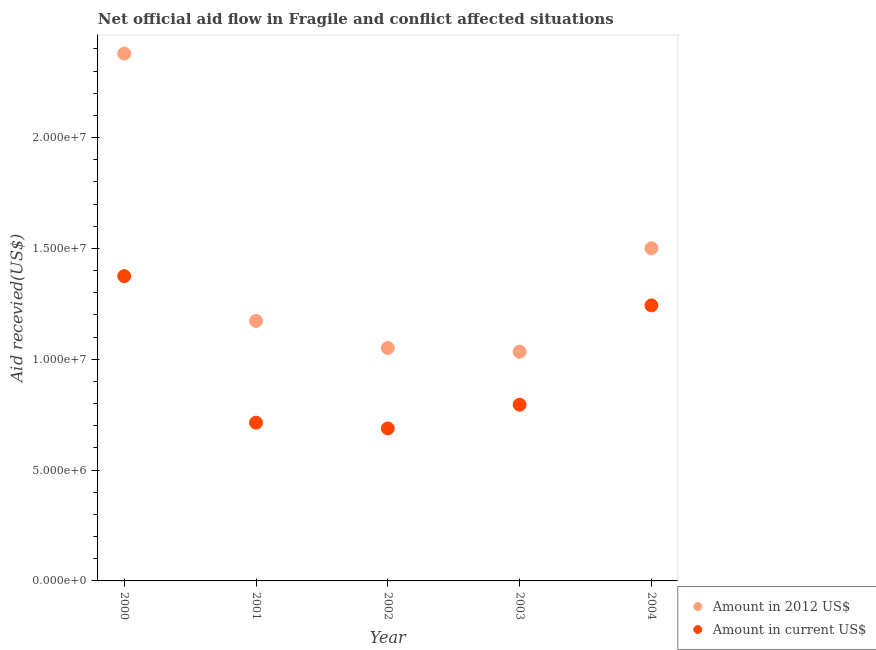How many different coloured dotlines are there?
Offer a terse response. 2. Is the number of dotlines equal to the number of legend labels?
Your answer should be very brief. Yes. What is the amount of aid received(expressed in 2012 us$) in 2003?
Give a very brief answer. 1.03e+07. Across all years, what is the maximum amount of aid received(expressed in us$)?
Provide a succinct answer. 1.38e+07. Across all years, what is the minimum amount of aid received(expressed in 2012 us$)?
Keep it short and to the point. 1.03e+07. In which year was the amount of aid received(expressed in 2012 us$) minimum?
Give a very brief answer. 2003. What is the total amount of aid received(expressed in us$) in the graph?
Your answer should be compact. 4.82e+07. What is the difference between the amount of aid received(expressed in us$) in 2000 and that in 2001?
Provide a succinct answer. 6.61e+06. What is the difference between the amount of aid received(expressed in 2012 us$) in 2002 and the amount of aid received(expressed in us$) in 2000?
Provide a short and direct response. -3.24e+06. What is the average amount of aid received(expressed in us$) per year?
Provide a succinct answer. 9.63e+06. In the year 2001, what is the difference between the amount of aid received(expressed in us$) and amount of aid received(expressed in 2012 us$)?
Your answer should be compact. -4.59e+06. What is the ratio of the amount of aid received(expressed in us$) in 2002 to that in 2003?
Ensure brevity in your answer.  0.87. Is the amount of aid received(expressed in us$) in 2001 less than that in 2003?
Your response must be concise. Yes. Is the difference between the amount of aid received(expressed in us$) in 2001 and 2004 greater than the difference between the amount of aid received(expressed in 2012 us$) in 2001 and 2004?
Your response must be concise. No. What is the difference between the highest and the second highest amount of aid received(expressed in us$)?
Make the answer very short. 1.32e+06. What is the difference between the highest and the lowest amount of aid received(expressed in 2012 us$)?
Your response must be concise. 1.34e+07. Does the amount of aid received(expressed in us$) monotonically increase over the years?
Your answer should be very brief. No. How many years are there in the graph?
Your answer should be very brief. 5. Does the graph contain any zero values?
Make the answer very short. No. How are the legend labels stacked?
Your answer should be compact. Vertical. What is the title of the graph?
Your answer should be compact. Net official aid flow in Fragile and conflict affected situations. Does "Subsidies" appear as one of the legend labels in the graph?
Offer a very short reply. No. What is the label or title of the X-axis?
Your response must be concise. Year. What is the label or title of the Y-axis?
Your answer should be compact. Aid recevied(US$). What is the Aid recevied(US$) in Amount in 2012 US$ in 2000?
Give a very brief answer. 2.38e+07. What is the Aid recevied(US$) in Amount in current US$ in 2000?
Your response must be concise. 1.38e+07. What is the Aid recevied(US$) in Amount in 2012 US$ in 2001?
Your answer should be very brief. 1.17e+07. What is the Aid recevied(US$) of Amount in current US$ in 2001?
Keep it short and to the point. 7.14e+06. What is the Aid recevied(US$) in Amount in 2012 US$ in 2002?
Your answer should be compact. 1.05e+07. What is the Aid recevied(US$) of Amount in current US$ in 2002?
Ensure brevity in your answer.  6.88e+06. What is the Aid recevied(US$) in Amount in 2012 US$ in 2003?
Your answer should be very brief. 1.03e+07. What is the Aid recevied(US$) in Amount in current US$ in 2003?
Keep it short and to the point. 7.95e+06. What is the Aid recevied(US$) in Amount in 2012 US$ in 2004?
Ensure brevity in your answer.  1.50e+07. What is the Aid recevied(US$) in Amount in current US$ in 2004?
Offer a terse response. 1.24e+07. Across all years, what is the maximum Aid recevied(US$) in Amount in 2012 US$?
Your answer should be compact. 2.38e+07. Across all years, what is the maximum Aid recevied(US$) in Amount in current US$?
Make the answer very short. 1.38e+07. Across all years, what is the minimum Aid recevied(US$) of Amount in 2012 US$?
Offer a terse response. 1.03e+07. Across all years, what is the minimum Aid recevied(US$) in Amount in current US$?
Offer a very short reply. 6.88e+06. What is the total Aid recevied(US$) of Amount in 2012 US$ in the graph?
Give a very brief answer. 7.14e+07. What is the total Aid recevied(US$) of Amount in current US$ in the graph?
Your response must be concise. 4.82e+07. What is the difference between the Aid recevied(US$) in Amount in 2012 US$ in 2000 and that in 2001?
Offer a very short reply. 1.21e+07. What is the difference between the Aid recevied(US$) of Amount in current US$ in 2000 and that in 2001?
Your answer should be very brief. 6.61e+06. What is the difference between the Aid recevied(US$) in Amount in 2012 US$ in 2000 and that in 2002?
Provide a short and direct response. 1.33e+07. What is the difference between the Aid recevied(US$) in Amount in current US$ in 2000 and that in 2002?
Give a very brief answer. 6.87e+06. What is the difference between the Aid recevied(US$) of Amount in 2012 US$ in 2000 and that in 2003?
Give a very brief answer. 1.34e+07. What is the difference between the Aid recevied(US$) of Amount in current US$ in 2000 and that in 2003?
Offer a very short reply. 5.80e+06. What is the difference between the Aid recevied(US$) of Amount in 2012 US$ in 2000 and that in 2004?
Keep it short and to the point. 8.78e+06. What is the difference between the Aid recevied(US$) in Amount in current US$ in 2000 and that in 2004?
Your response must be concise. 1.32e+06. What is the difference between the Aid recevied(US$) in Amount in 2012 US$ in 2001 and that in 2002?
Your answer should be very brief. 1.22e+06. What is the difference between the Aid recevied(US$) in Amount in 2012 US$ in 2001 and that in 2003?
Provide a succinct answer. 1.39e+06. What is the difference between the Aid recevied(US$) in Amount in current US$ in 2001 and that in 2003?
Provide a succinct answer. -8.10e+05. What is the difference between the Aid recevied(US$) in Amount in 2012 US$ in 2001 and that in 2004?
Provide a short and direct response. -3.28e+06. What is the difference between the Aid recevied(US$) in Amount in current US$ in 2001 and that in 2004?
Your response must be concise. -5.29e+06. What is the difference between the Aid recevied(US$) in Amount in current US$ in 2002 and that in 2003?
Provide a succinct answer. -1.07e+06. What is the difference between the Aid recevied(US$) in Amount in 2012 US$ in 2002 and that in 2004?
Give a very brief answer. -4.50e+06. What is the difference between the Aid recevied(US$) of Amount in current US$ in 2002 and that in 2004?
Provide a short and direct response. -5.55e+06. What is the difference between the Aid recevied(US$) of Amount in 2012 US$ in 2003 and that in 2004?
Provide a succinct answer. -4.67e+06. What is the difference between the Aid recevied(US$) in Amount in current US$ in 2003 and that in 2004?
Your response must be concise. -4.48e+06. What is the difference between the Aid recevied(US$) of Amount in 2012 US$ in 2000 and the Aid recevied(US$) of Amount in current US$ in 2001?
Keep it short and to the point. 1.66e+07. What is the difference between the Aid recevied(US$) in Amount in 2012 US$ in 2000 and the Aid recevied(US$) in Amount in current US$ in 2002?
Offer a terse response. 1.69e+07. What is the difference between the Aid recevied(US$) in Amount in 2012 US$ in 2000 and the Aid recevied(US$) in Amount in current US$ in 2003?
Provide a succinct answer. 1.58e+07. What is the difference between the Aid recevied(US$) of Amount in 2012 US$ in 2000 and the Aid recevied(US$) of Amount in current US$ in 2004?
Your response must be concise. 1.14e+07. What is the difference between the Aid recevied(US$) of Amount in 2012 US$ in 2001 and the Aid recevied(US$) of Amount in current US$ in 2002?
Make the answer very short. 4.85e+06. What is the difference between the Aid recevied(US$) of Amount in 2012 US$ in 2001 and the Aid recevied(US$) of Amount in current US$ in 2003?
Provide a short and direct response. 3.78e+06. What is the difference between the Aid recevied(US$) in Amount in 2012 US$ in 2001 and the Aid recevied(US$) in Amount in current US$ in 2004?
Offer a very short reply. -7.00e+05. What is the difference between the Aid recevied(US$) in Amount in 2012 US$ in 2002 and the Aid recevied(US$) in Amount in current US$ in 2003?
Offer a terse response. 2.56e+06. What is the difference between the Aid recevied(US$) of Amount in 2012 US$ in 2002 and the Aid recevied(US$) of Amount in current US$ in 2004?
Your answer should be compact. -1.92e+06. What is the difference between the Aid recevied(US$) in Amount in 2012 US$ in 2003 and the Aid recevied(US$) in Amount in current US$ in 2004?
Offer a terse response. -2.09e+06. What is the average Aid recevied(US$) in Amount in 2012 US$ per year?
Your answer should be compact. 1.43e+07. What is the average Aid recevied(US$) of Amount in current US$ per year?
Give a very brief answer. 9.63e+06. In the year 2000, what is the difference between the Aid recevied(US$) in Amount in 2012 US$ and Aid recevied(US$) in Amount in current US$?
Provide a succinct answer. 1.00e+07. In the year 2001, what is the difference between the Aid recevied(US$) of Amount in 2012 US$ and Aid recevied(US$) of Amount in current US$?
Keep it short and to the point. 4.59e+06. In the year 2002, what is the difference between the Aid recevied(US$) in Amount in 2012 US$ and Aid recevied(US$) in Amount in current US$?
Make the answer very short. 3.63e+06. In the year 2003, what is the difference between the Aid recevied(US$) of Amount in 2012 US$ and Aid recevied(US$) of Amount in current US$?
Ensure brevity in your answer.  2.39e+06. In the year 2004, what is the difference between the Aid recevied(US$) of Amount in 2012 US$ and Aid recevied(US$) of Amount in current US$?
Give a very brief answer. 2.58e+06. What is the ratio of the Aid recevied(US$) in Amount in 2012 US$ in 2000 to that in 2001?
Your answer should be compact. 2.03. What is the ratio of the Aid recevied(US$) in Amount in current US$ in 2000 to that in 2001?
Your response must be concise. 1.93. What is the ratio of the Aid recevied(US$) in Amount in 2012 US$ in 2000 to that in 2002?
Make the answer very short. 2.26. What is the ratio of the Aid recevied(US$) in Amount in current US$ in 2000 to that in 2002?
Provide a succinct answer. 2. What is the ratio of the Aid recevied(US$) of Amount in 2012 US$ in 2000 to that in 2003?
Offer a terse response. 2.3. What is the ratio of the Aid recevied(US$) in Amount in current US$ in 2000 to that in 2003?
Offer a terse response. 1.73. What is the ratio of the Aid recevied(US$) in Amount in 2012 US$ in 2000 to that in 2004?
Provide a succinct answer. 1.58. What is the ratio of the Aid recevied(US$) of Amount in current US$ in 2000 to that in 2004?
Your answer should be compact. 1.11. What is the ratio of the Aid recevied(US$) in Amount in 2012 US$ in 2001 to that in 2002?
Keep it short and to the point. 1.12. What is the ratio of the Aid recevied(US$) in Amount in current US$ in 2001 to that in 2002?
Your response must be concise. 1.04. What is the ratio of the Aid recevied(US$) in Amount in 2012 US$ in 2001 to that in 2003?
Make the answer very short. 1.13. What is the ratio of the Aid recevied(US$) in Amount in current US$ in 2001 to that in 2003?
Make the answer very short. 0.9. What is the ratio of the Aid recevied(US$) of Amount in 2012 US$ in 2001 to that in 2004?
Offer a very short reply. 0.78. What is the ratio of the Aid recevied(US$) of Amount in current US$ in 2001 to that in 2004?
Offer a terse response. 0.57. What is the ratio of the Aid recevied(US$) of Amount in 2012 US$ in 2002 to that in 2003?
Keep it short and to the point. 1.02. What is the ratio of the Aid recevied(US$) of Amount in current US$ in 2002 to that in 2003?
Your answer should be compact. 0.87. What is the ratio of the Aid recevied(US$) of Amount in 2012 US$ in 2002 to that in 2004?
Offer a terse response. 0.7. What is the ratio of the Aid recevied(US$) of Amount in current US$ in 2002 to that in 2004?
Offer a very short reply. 0.55. What is the ratio of the Aid recevied(US$) of Amount in 2012 US$ in 2003 to that in 2004?
Give a very brief answer. 0.69. What is the ratio of the Aid recevied(US$) in Amount in current US$ in 2003 to that in 2004?
Give a very brief answer. 0.64. What is the difference between the highest and the second highest Aid recevied(US$) in Amount in 2012 US$?
Make the answer very short. 8.78e+06. What is the difference between the highest and the second highest Aid recevied(US$) in Amount in current US$?
Ensure brevity in your answer.  1.32e+06. What is the difference between the highest and the lowest Aid recevied(US$) of Amount in 2012 US$?
Provide a short and direct response. 1.34e+07. What is the difference between the highest and the lowest Aid recevied(US$) in Amount in current US$?
Give a very brief answer. 6.87e+06. 